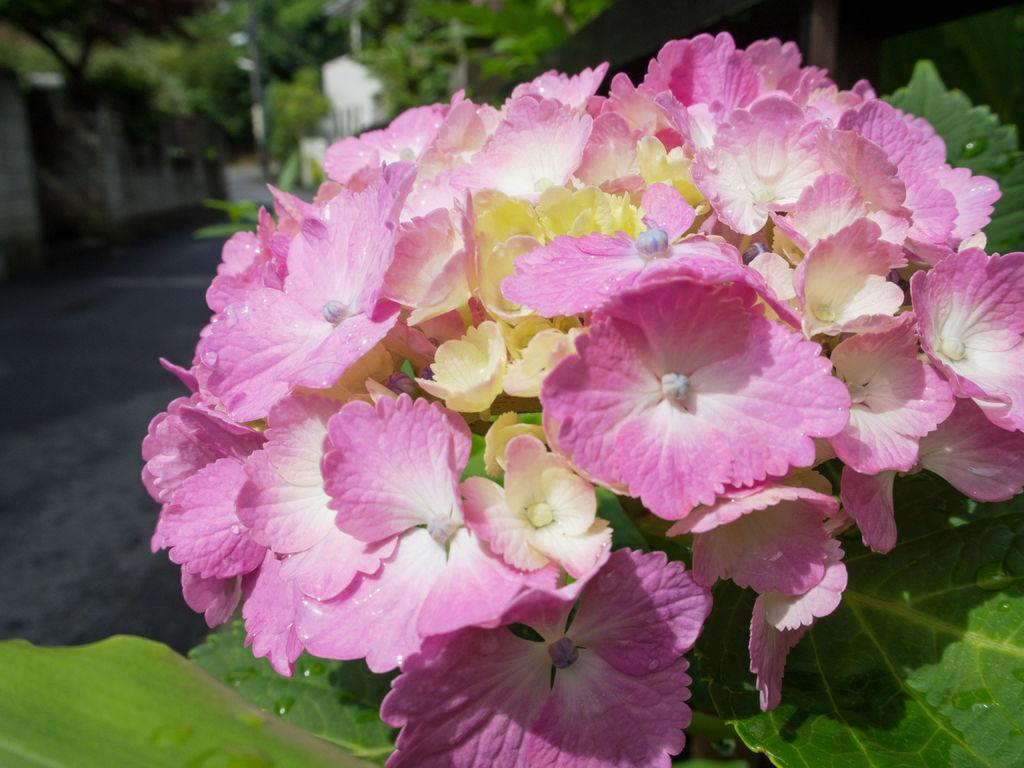What type of plants can be seen in the image? There are flowers in the image. Where are the flowers located in relation to the image? The flowers are in the front of the image. What else can be seen in the background of the image? There are trees in the background of the image. What substance is the flowers using to communicate with each other in the image? There is no indication in the image that the flowers are communicating with each other or using any substance for that purpose. 